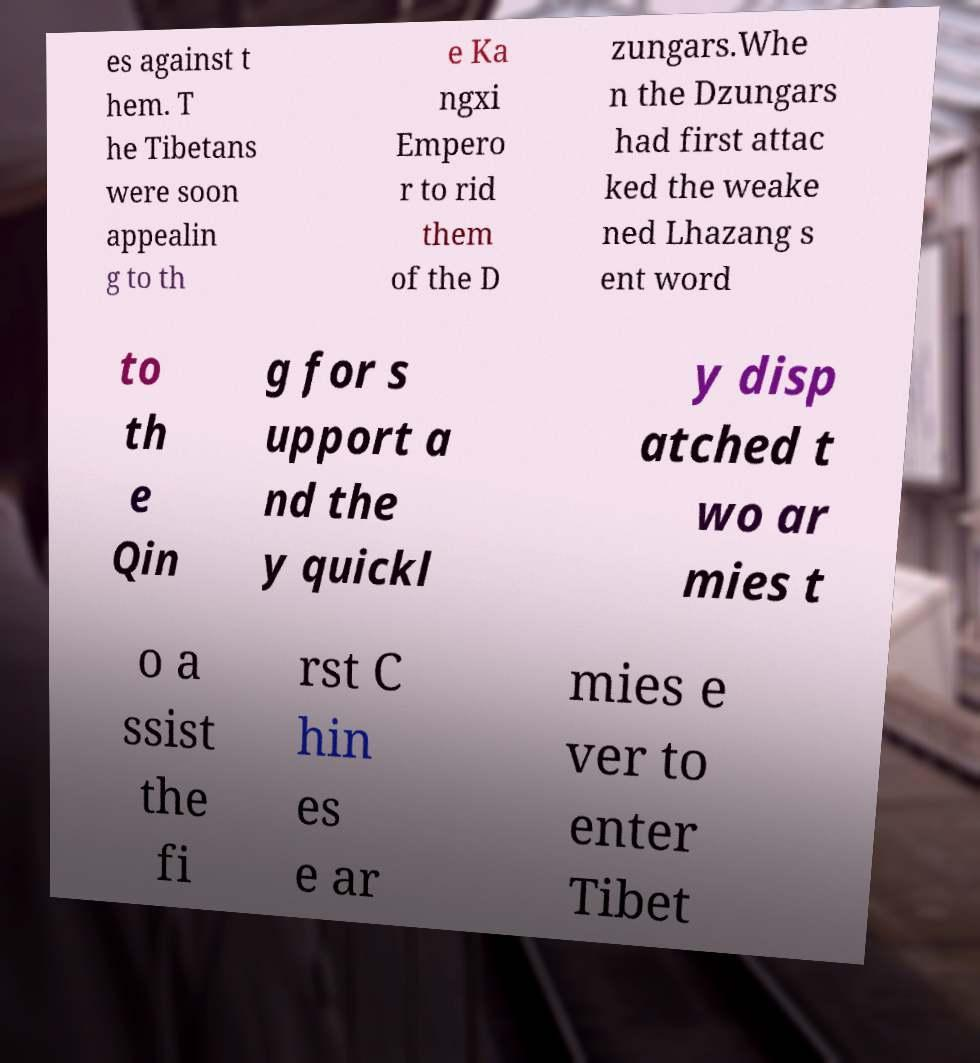I need the written content from this picture converted into text. Can you do that? es against t hem. T he Tibetans were soon appealin g to th e Ka ngxi Empero r to rid them of the D zungars.Whe n the Dzungars had first attac ked the weake ned Lhazang s ent word to th e Qin g for s upport a nd the y quickl y disp atched t wo ar mies t o a ssist the fi rst C hin es e ar mies e ver to enter Tibet 